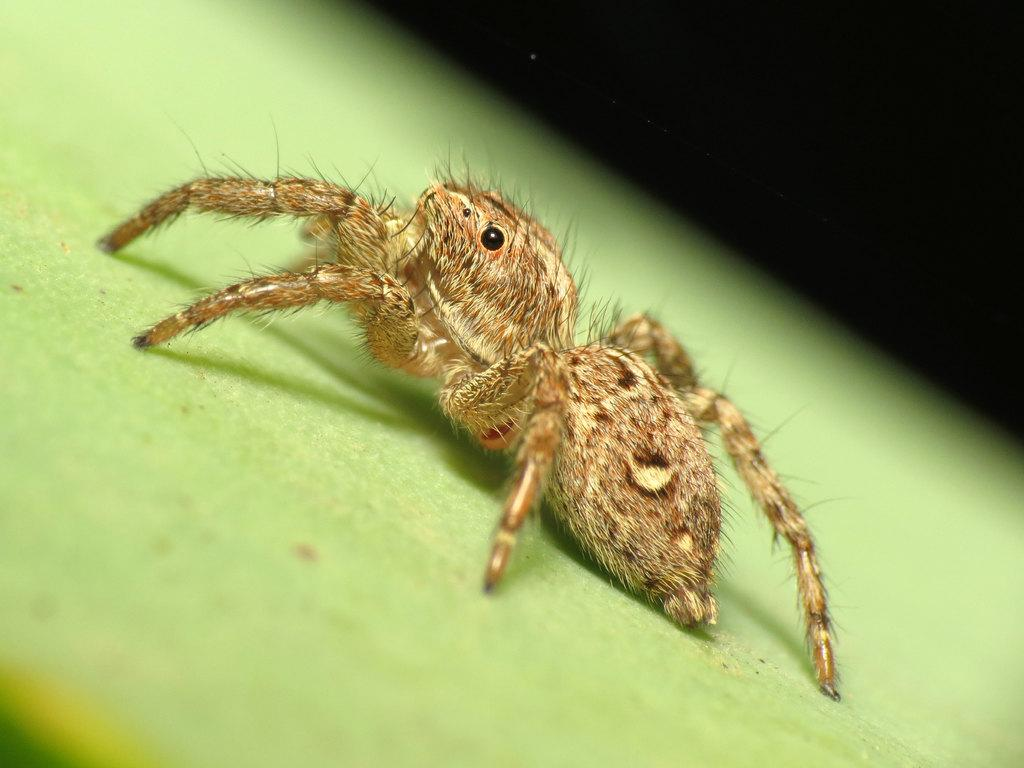What color is the surface in the image? The surface in the image is green. What is present on the green surface? There is an insect on the green surface. What can be seen in the background of the image? The background of the image is dark. What type of bun is being prepared in the image? There is no bun present in the image; it features a green surface with an insect on it. What kind of joke is being told by the insect in the image? There is no joke being told in the image; it simply shows an insect on a green surface. 